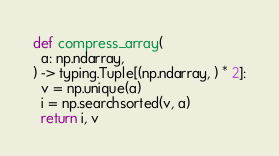<code> <loc_0><loc_0><loc_500><loc_500><_Python_>def compress_array(
  a: np.ndarray,
) -> typing.Tuple[(np.ndarray, ) * 2]:
  v = np.unique(a)
  i = np.searchsorted(v, a)
  return i, v
</code> 